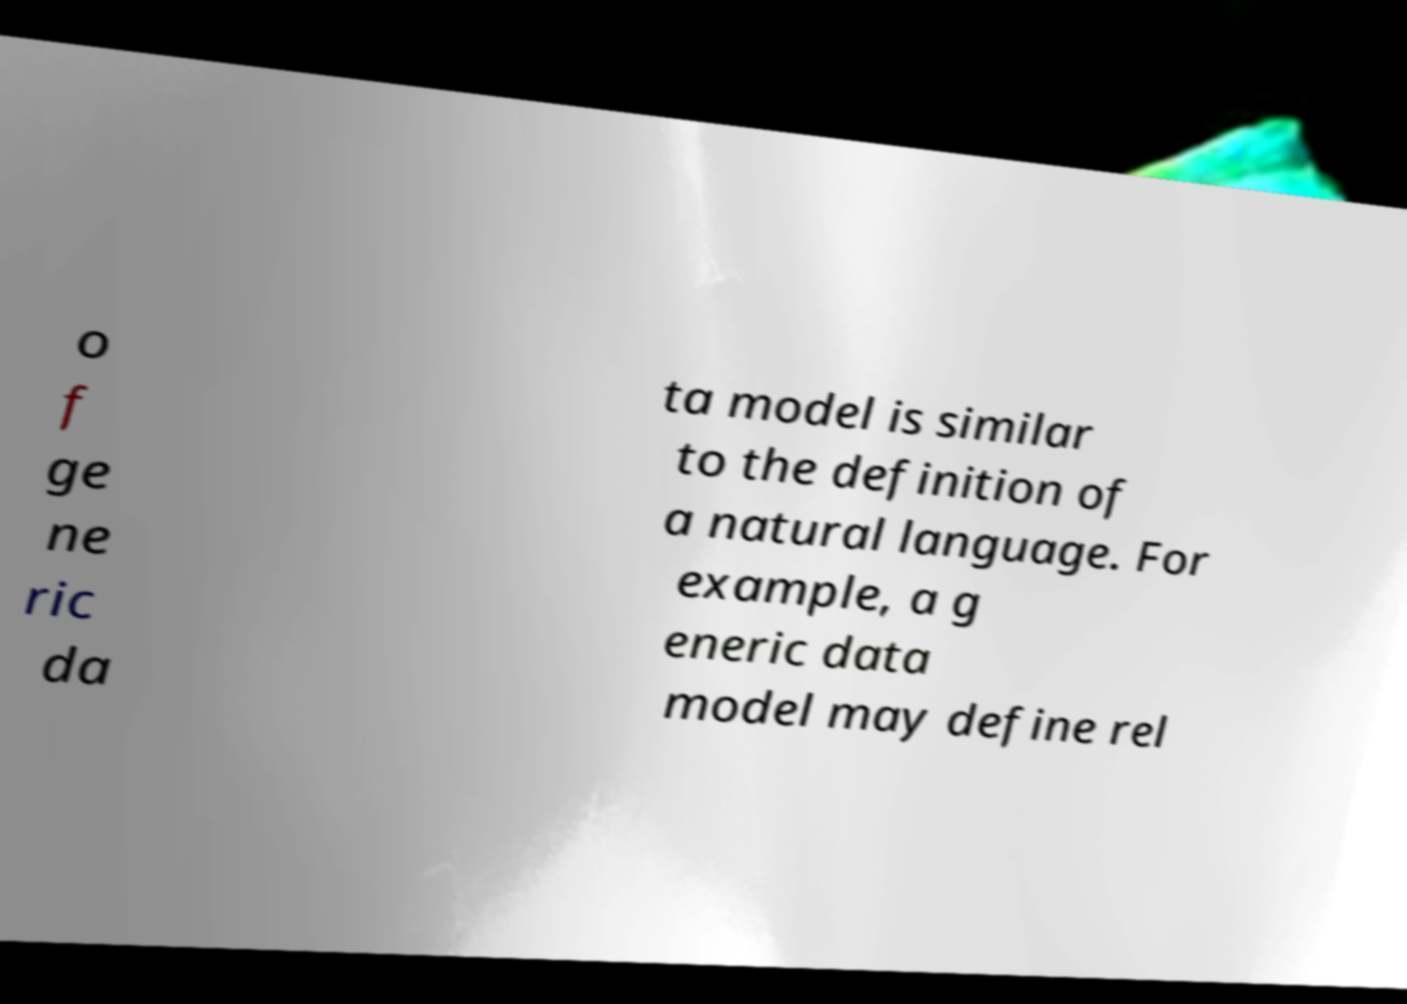Can you accurately transcribe the text from the provided image for me? o f ge ne ric da ta model is similar to the definition of a natural language. For example, a g eneric data model may define rel 